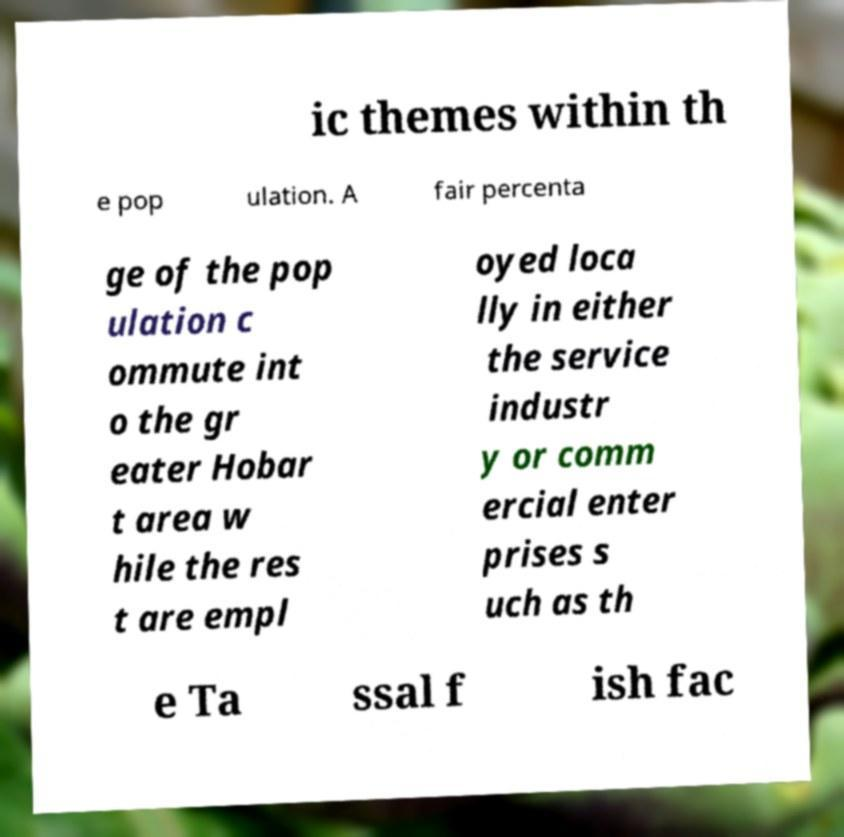Please read and relay the text visible in this image. What does it say? ic themes within th e pop ulation. A fair percenta ge of the pop ulation c ommute int o the gr eater Hobar t area w hile the res t are empl oyed loca lly in either the service industr y or comm ercial enter prises s uch as th e Ta ssal f ish fac 